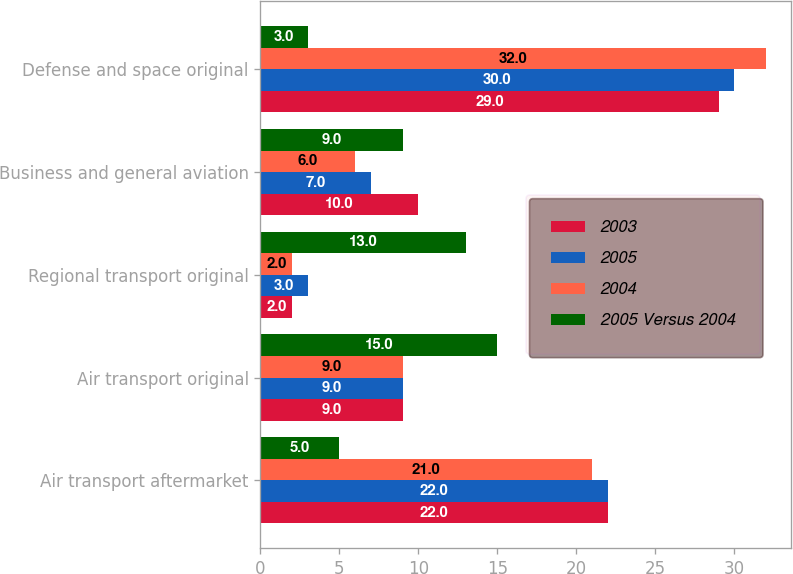Convert chart to OTSL. <chart><loc_0><loc_0><loc_500><loc_500><stacked_bar_chart><ecel><fcel>Air transport aftermarket<fcel>Air transport original<fcel>Regional transport original<fcel>Business and general aviation<fcel>Defense and space original<nl><fcel>2003<fcel>22<fcel>9<fcel>2<fcel>10<fcel>29<nl><fcel>2005<fcel>22<fcel>9<fcel>3<fcel>7<fcel>30<nl><fcel>2004<fcel>21<fcel>9<fcel>2<fcel>6<fcel>32<nl><fcel>2005 Versus 2004<fcel>5<fcel>15<fcel>13<fcel>9<fcel>3<nl></chart> 